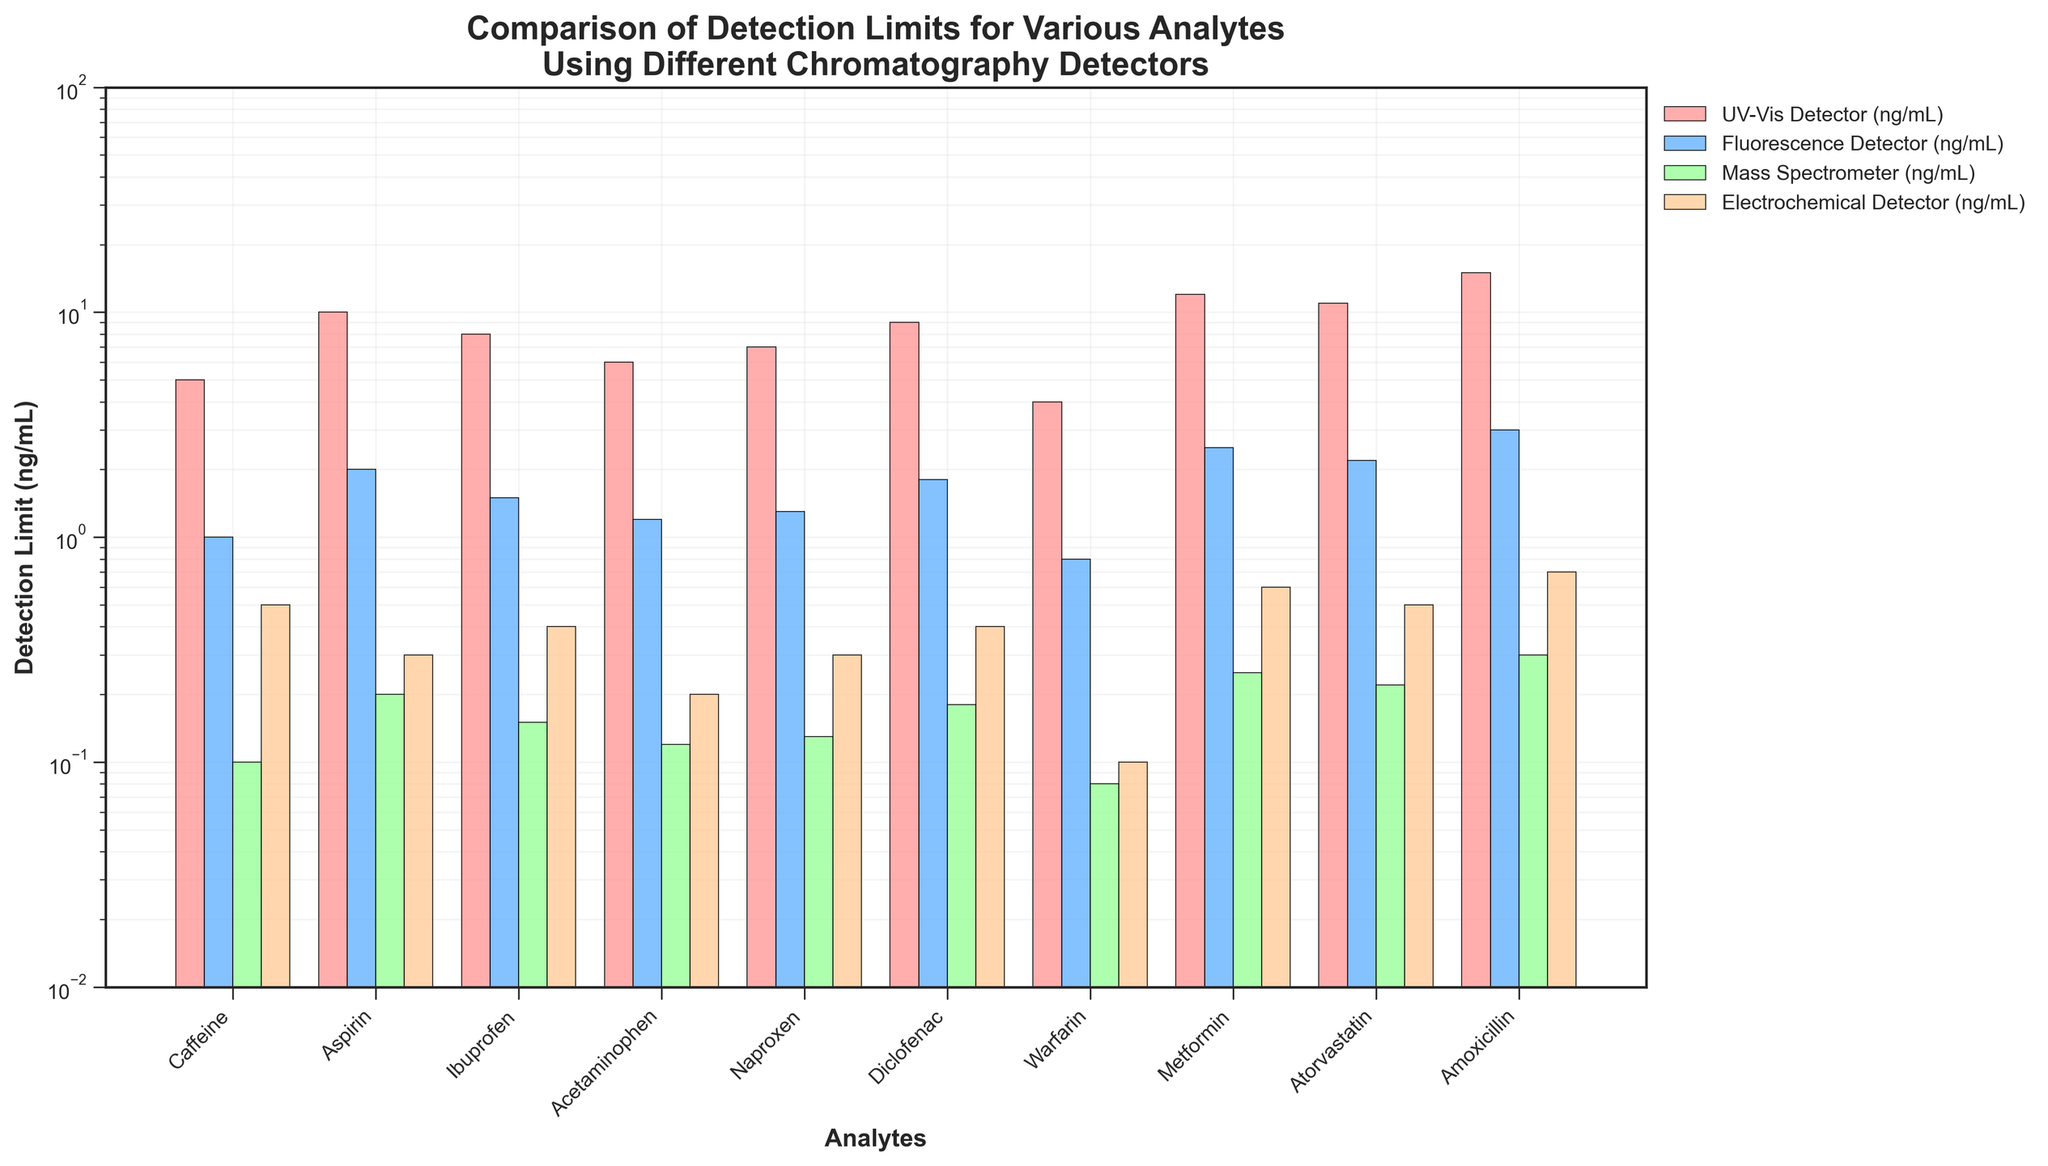Which analyte has the lowest detection limit using the mass spectrometer? Look at the bars representing the mass spectrometer for each analyte and find the one with the lowest height. Warfarin has the shortest bar for the mass spectrometer.
Answer: Warfarin How much higher is the detection limit of caffeine using the UV-Vis detector compared to the fluorescence detector? Compare the detection limits of caffeine using the UV-Vis detector and the fluorescence detector. Subtract the value for the fluorescence detector (1 ng/mL) from the UV-Vis detector (5 ng/mL).
Answer: 4 ng/mL Which detector shows the most variation in detection limits across the analytes? Check the range of heights of the bars for each detector across the analytes. The UV-Vis detector has the widest range, with values from 4 ng/mL to 15 ng/mL.
Answer: UV-Vis detector What is the average detection limit for ibuprofen across all detectors? Add the detection limits for ibuprofen using each detector: UV-Vis (8), Fluorescence (1.5), Mass Spectrometer (0.15), and Electrochemical (0.4). Sum these values (8 + 1.5 + 0.15 + 0.4 = 10.05) and divide by 4.
Answer: 2.51 ng/mL Is there any analyte where the detection limit using the electrochemical detector is equal to or lower than that using the mass spectrometer? Compare the detection limits for each analyte using the electrochemical detector and the mass spectrometer. Warfarin has lower detection limits using the electrochemical detector (0.1 ng/mL) compared to the mass spectrometer (0.08 ng/mL).
Answer: No Which analyte has the highest detection limit using the electrochemical detector? Look at the bar heights for each analyte for the electrochemical detector and identify the highest one. Amoxicillin has the highest detection limit using the electrochemical detector at 0.7 ng/mL.
Answer: Amoxicillin How many analytes have a detection limit below 1 ng/mL with the mass spectrometer? Count the number of analytes where the mass spectrometer’s detection limit bars are below the 1 ng/mL line. There are 8 analytes (Caffeine, Aspirin, Ibuprofen, Acetaminophen, Naproxen, Diclofenac, Warfarin, Atorvastatin).
Answer: Eight Compare the detection limits of amoxicillin for the UV-Vis and fluorescence detectors. Which one is higher and by how much? Check the detection limits of amoxicillin: UV-Vis (15 ng/mL) and fluorescence (3 ng/mL). Subtract the fluorescence value from the UV-Vis value.
Answer: UV-Vis, by 12 ng/mL Which detector consistently has the lowest detection limits across most analytes? Observe the lowest bar heights for each analyte. The mass spectrometer consistently has the lowest detection limits across the analytes.
Answer: Mass spectrometer What is the range of detection limits for acetaminophen across all detectors? Identify the highest (UV-Vis, 6 ng/mL) and lowest (Mass Spectrometer, 0.12 ng/mL) detection limits for acetaminophen. Subtract the lowest value from the highest value.
Answer: 5.88 ng/mL 